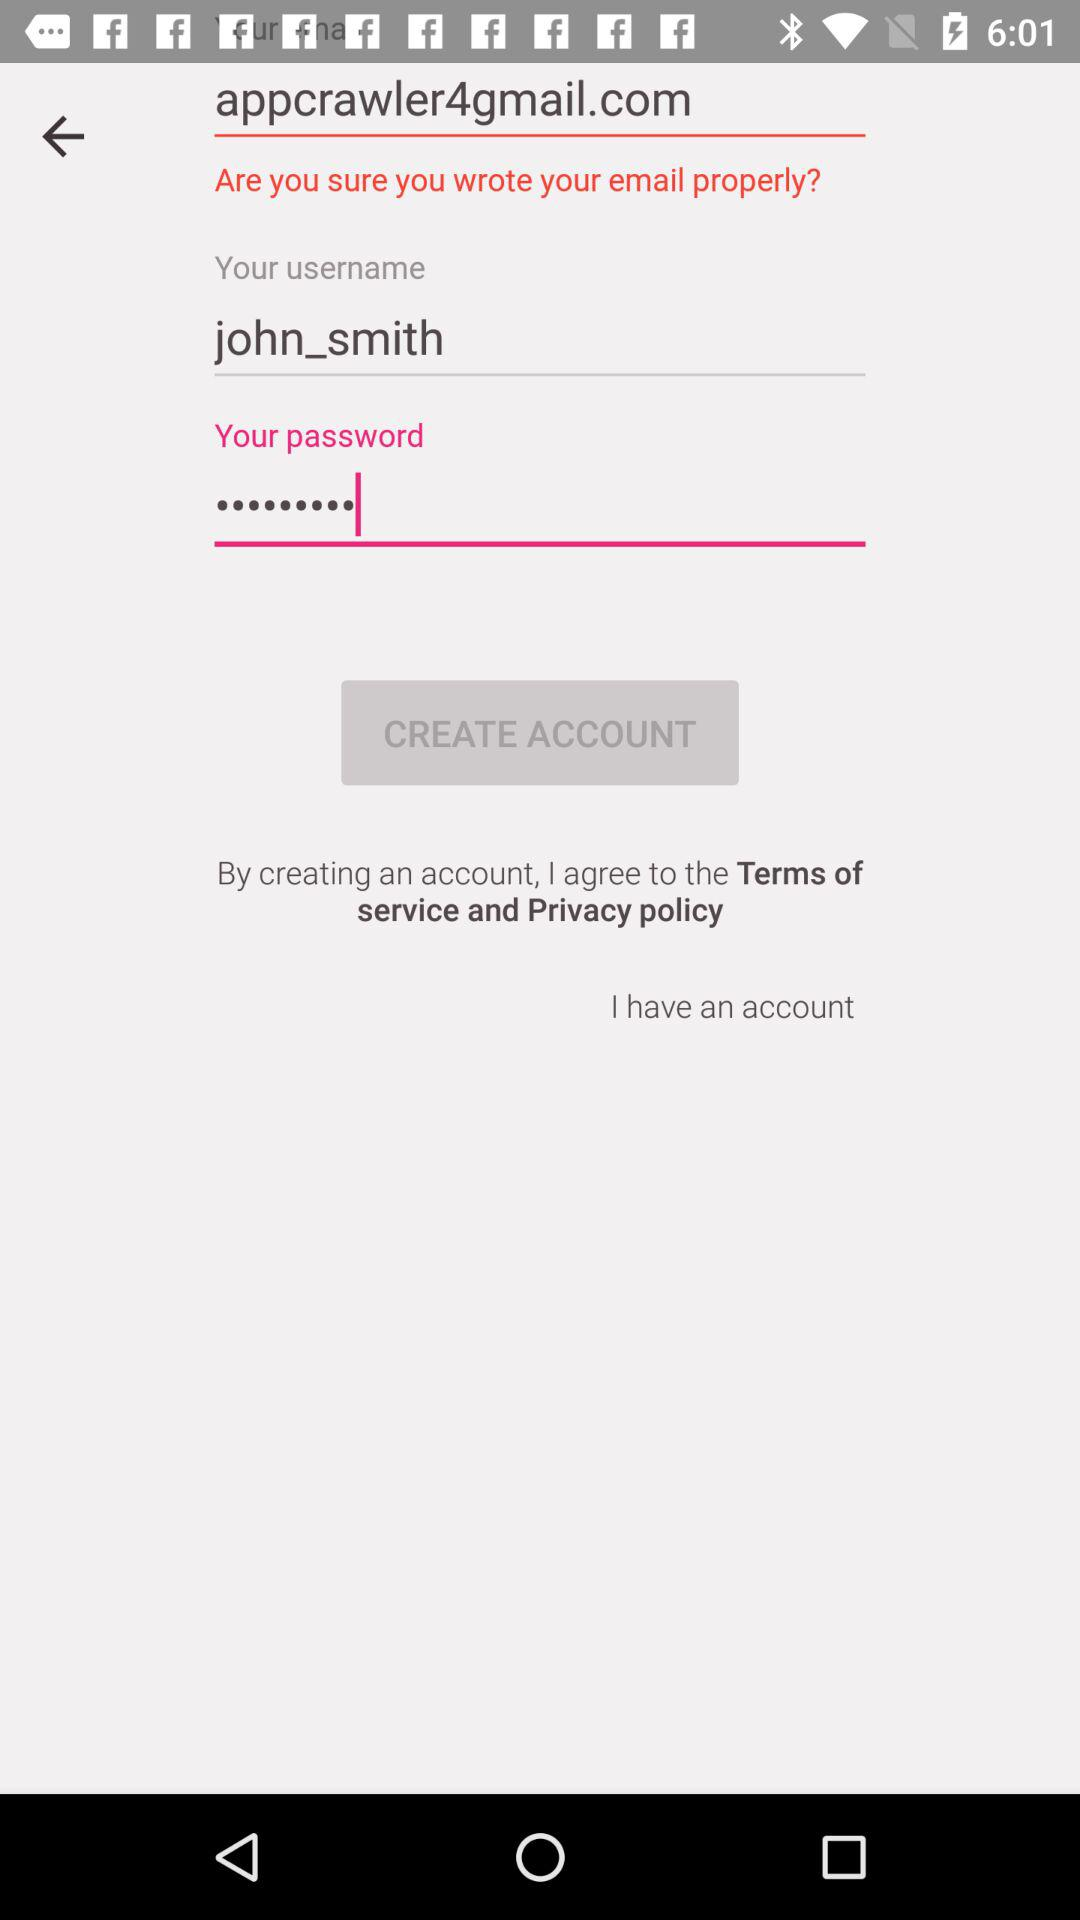What is the email address? The email address is appcrawler4@gmail.com. 